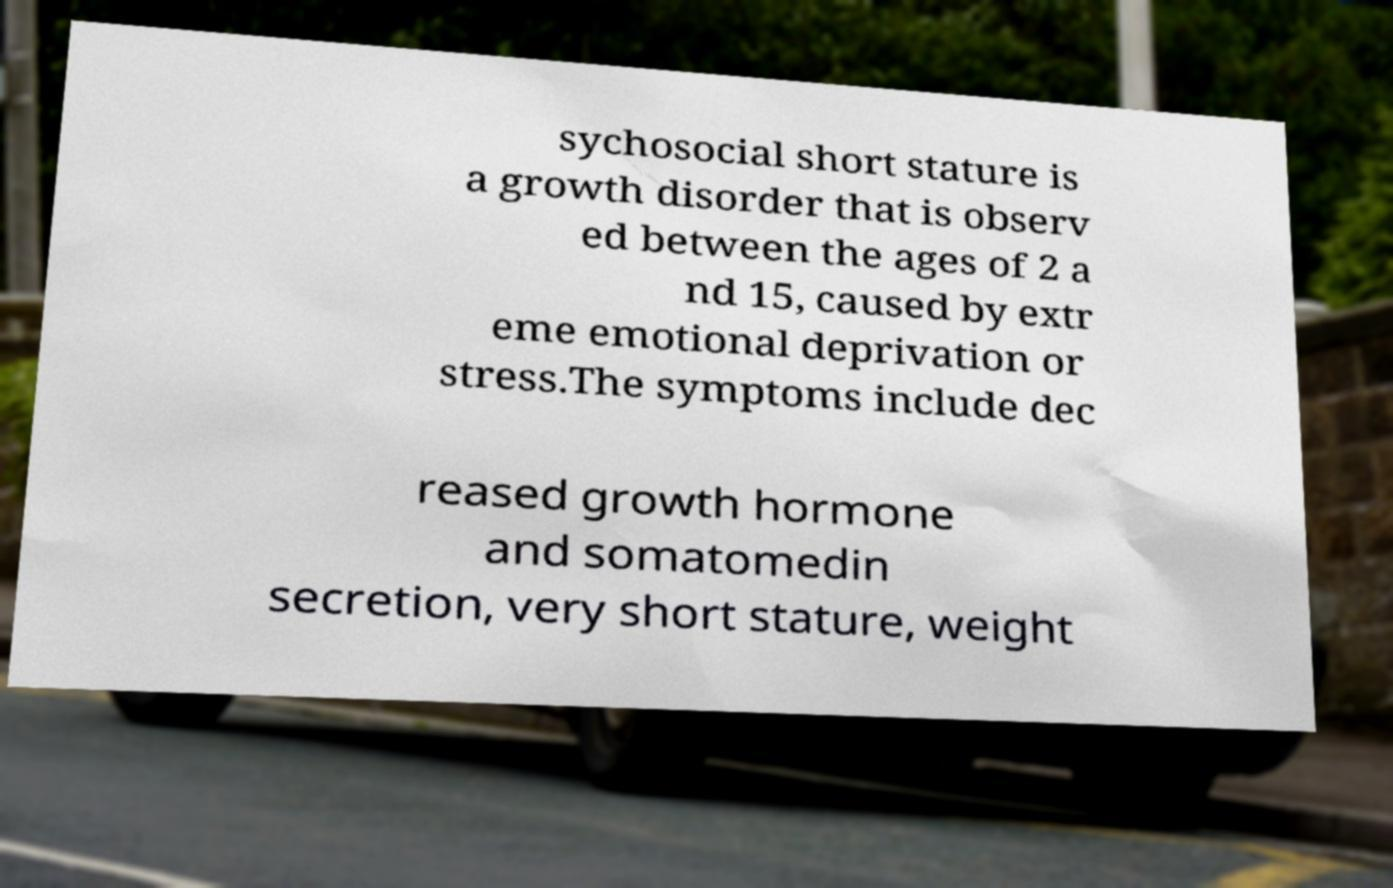For documentation purposes, I need the text within this image transcribed. Could you provide that? sychosocial short stature is a growth disorder that is observ ed between the ages of 2 a nd 15, caused by extr eme emotional deprivation or stress.The symptoms include dec reased growth hormone and somatomedin secretion, very short stature, weight 